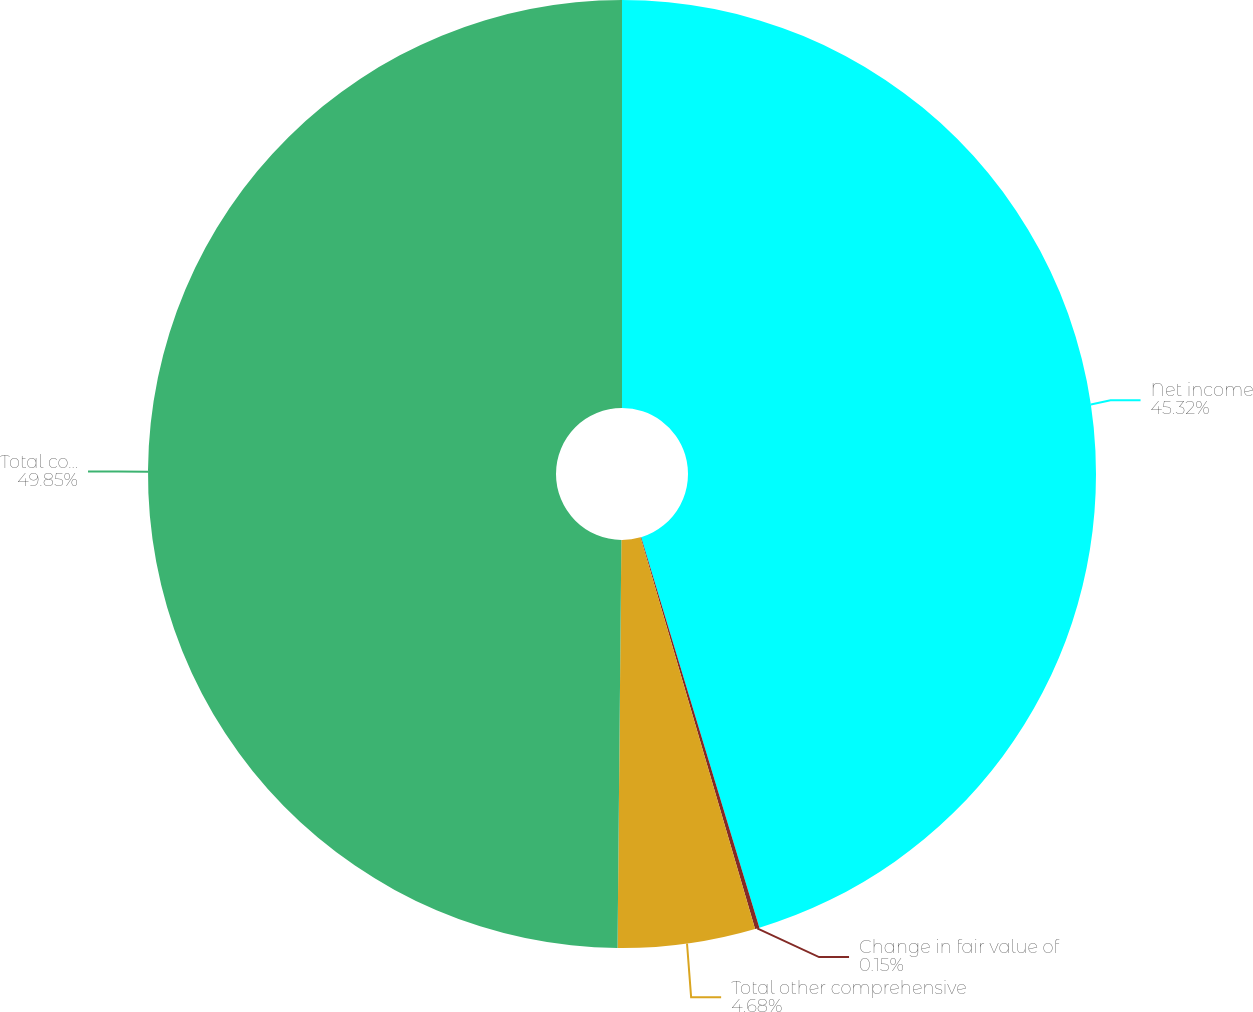<chart> <loc_0><loc_0><loc_500><loc_500><pie_chart><fcel>Net income<fcel>Change in fair value of<fcel>Total other comprehensive<fcel>Total comprehensive income<nl><fcel>45.32%<fcel>0.15%<fcel>4.68%<fcel>49.85%<nl></chart> 